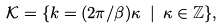Convert formula to latex. <formula><loc_0><loc_0><loc_500><loc_500>\mathcal { K } = \{ k = ( 2 \pi / \beta ) \kappa \ | \ \kappa \in \mathbb { Z } \} ,</formula> 